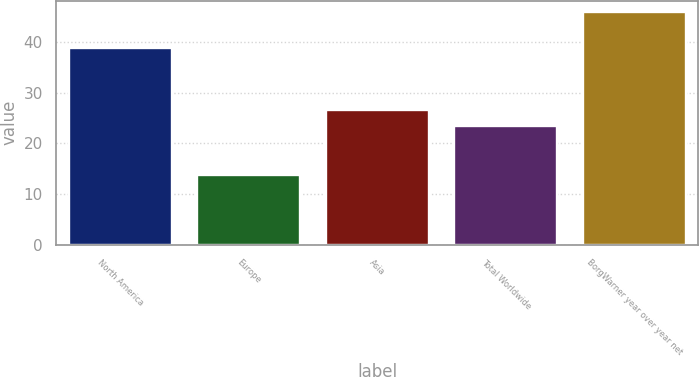Convert chart. <chart><loc_0><loc_0><loc_500><loc_500><bar_chart><fcel>North America<fcel>Europe<fcel>Asia<fcel>Total Worldwide<fcel>BorgWarner year over year net<nl><fcel>38.8<fcel>13.7<fcel>26.63<fcel>23.5<fcel>45.83<nl></chart> 